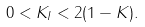<formula> <loc_0><loc_0><loc_500><loc_500>0 < K _ { I } < 2 ( 1 - K ) .</formula> 